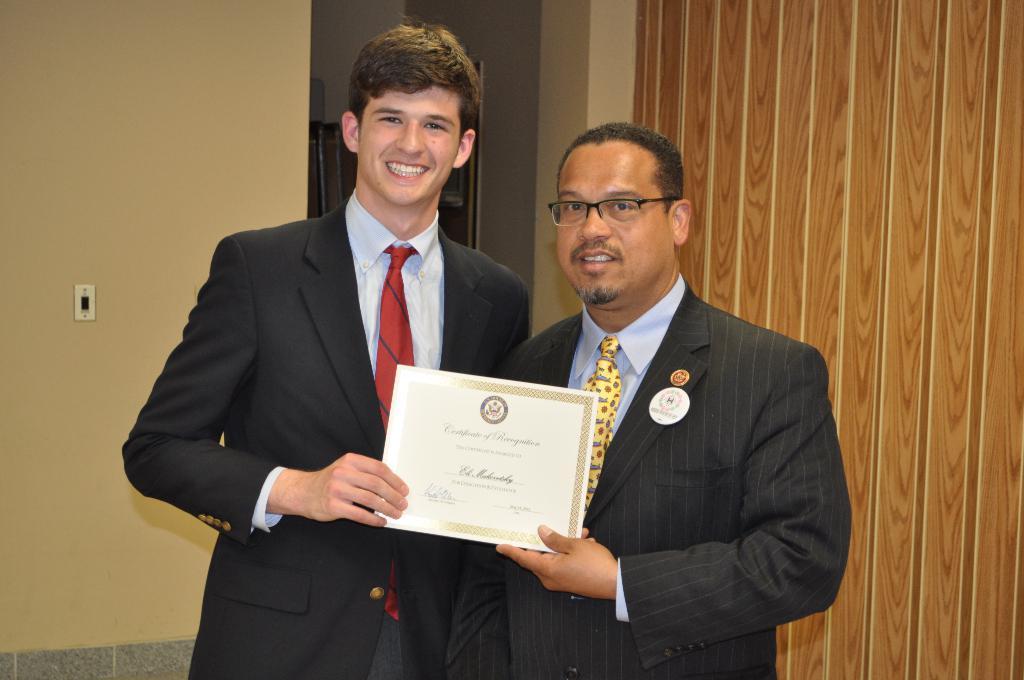How would you summarize this image in a sentence or two? In the center of the image we can see a few people are standing and they are holding one object. And we can see they are smiling and the right side person is wearing glasses. In the background there is a wall, switchboard, frame and a few other objects. 